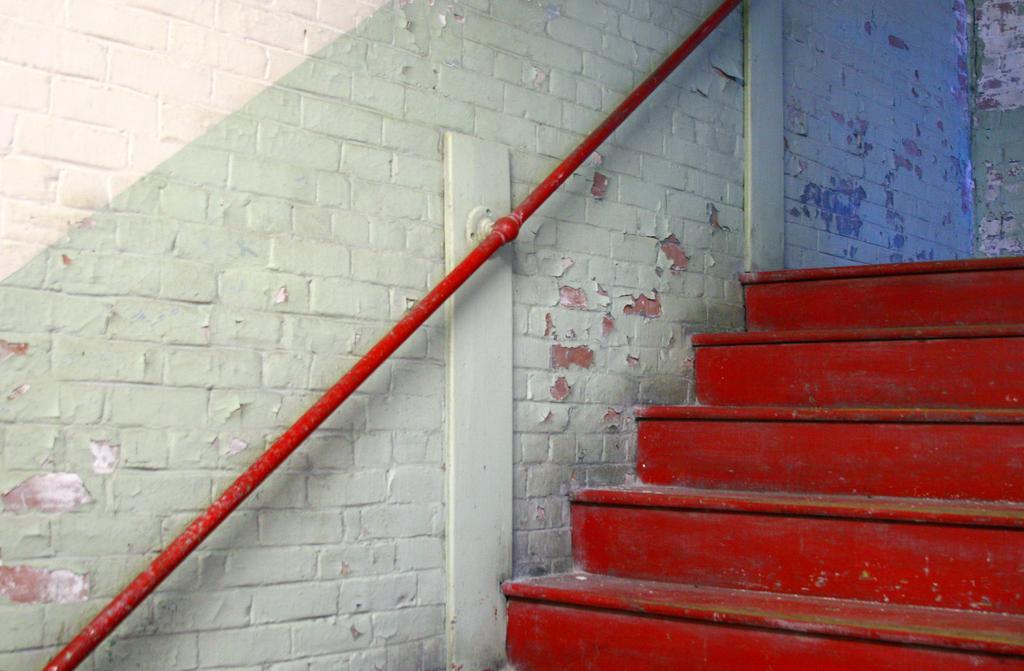Describe this image in one or two sentences. In this image in the center there is a staircase, and in the background there is a wall and a pole. 